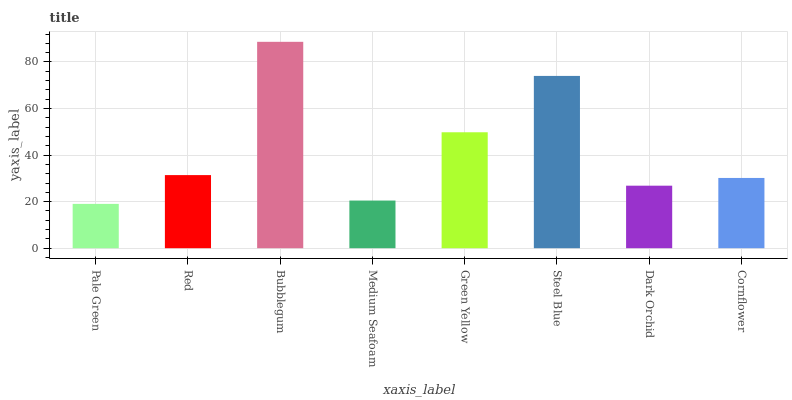Is Pale Green the minimum?
Answer yes or no. Yes. Is Bubblegum the maximum?
Answer yes or no. Yes. Is Red the minimum?
Answer yes or no. No. Is Red the maximum?
Answer yes or no. No. Is Red greater than Pale Green?
Answer yes or no. Yes. Is Pale Green less than Red?
Answer yes or no. Yes. Is Pale Green greater than Red?
Answer yes or no. No. Is Red less than Pale Green?
Answer yes or no. No. Is Red the high median?
Answer yes or no. Yes. Is Cornflower the low median?
Answer yes or no. Yes. Is Bubblegum the high median?
Answer yes or no. No. Is Medium Seafoam the low median?
Answer yes or no. No. 